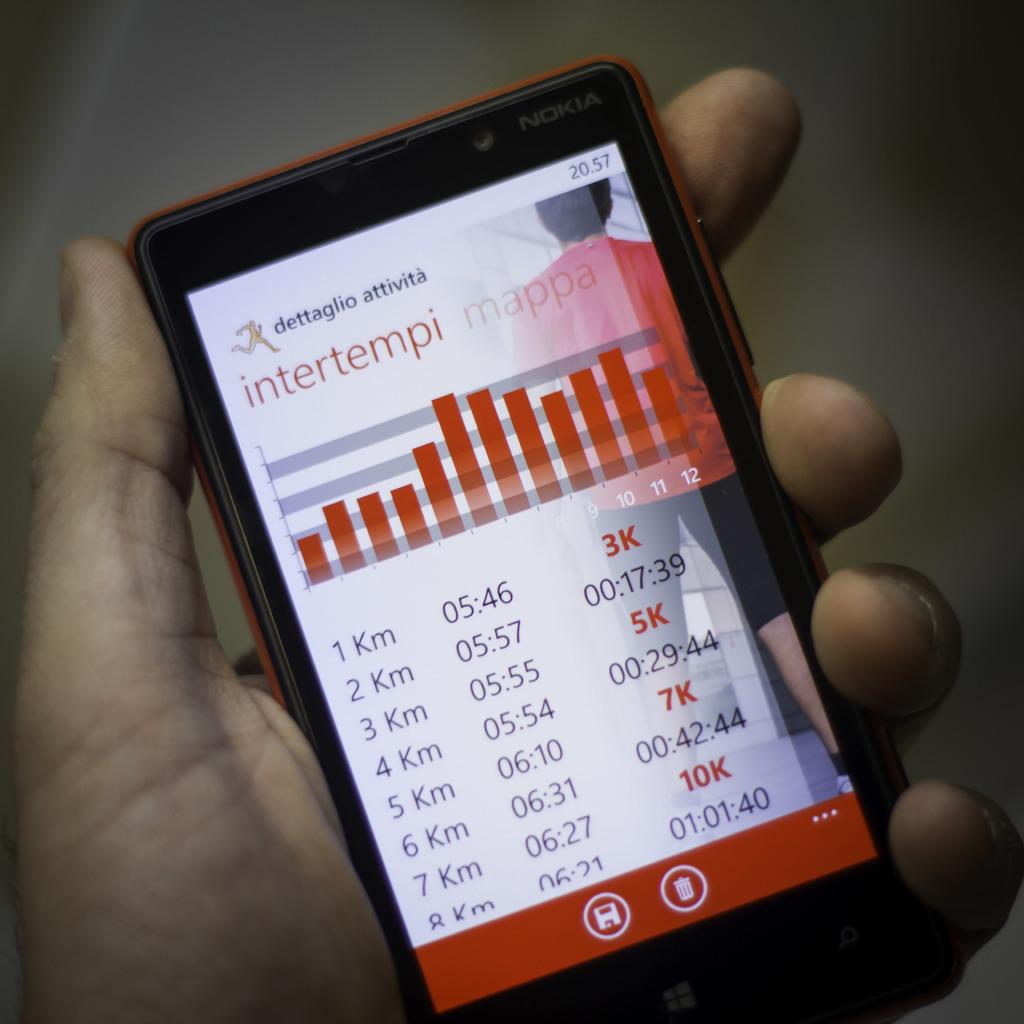What is displayed on the mobile in the image? Data is visible on a mobile display in the image. How is the mobile being held in the image? Someone is holding the mobile in their hand. What type of rabbit can be seen adjusting the mobile's settings in the image? There is no rabbit present in the image, and the mobile's settings are not being adjusted. 